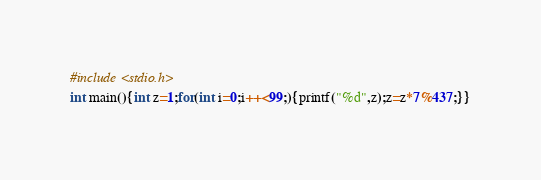<code> <loc_0><loc_0><loc_500><loc_500><_C_>#include <stdio.h>
int main(){int z=1;for(int i=0;i++<99;){printf("%d",z);z=z*7%437;}}</code> 